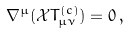Convert formula to latex. <formula><loc_0><loc_0><loc_500><loc_500>\nabla ^ { \mu } ( \mathcal { X } T ^ { ( c ) } _ { \mu \nu } ) = 0 \, ,</formula> 